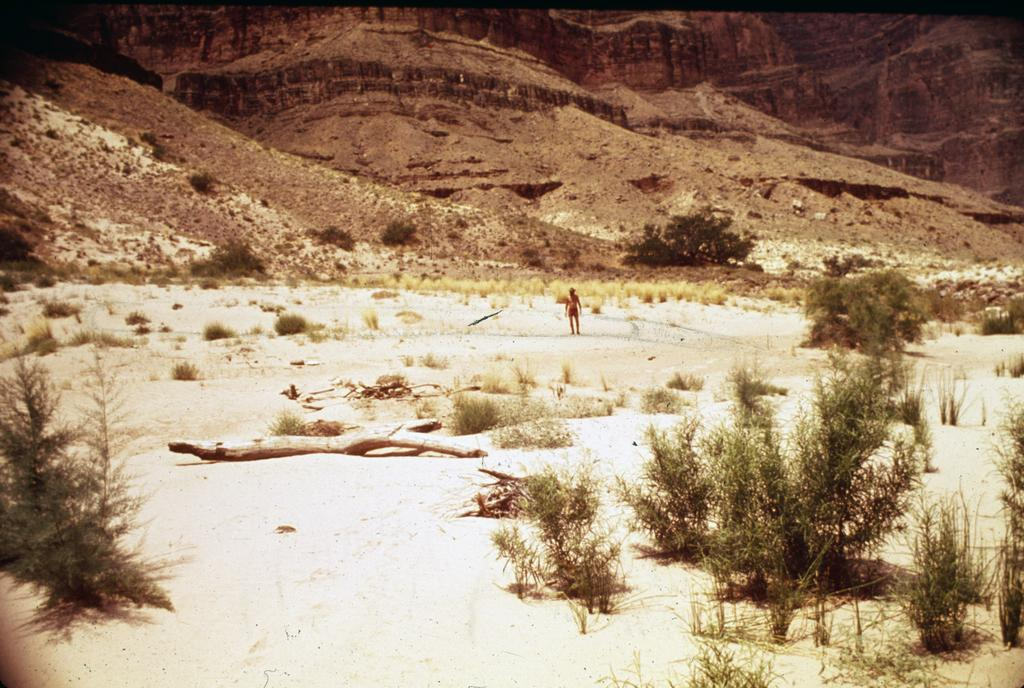What type of vegetation can be seen in the image? There are plants and grass in the image. Where are the plants and grass located? The plants and grass are on a land in the image. What is the person in the image doing? There is a person standing on the land in the image. What can be seen in the background of the image? There are mountains in the background of the image. What type of clam can be seen in the image? There is no clam present in the image; it features plants, grass, a person, and mountains. What song is the person singing in the image? There is no indication in the image that the person is singing, so it cannot be determined from the picture. 